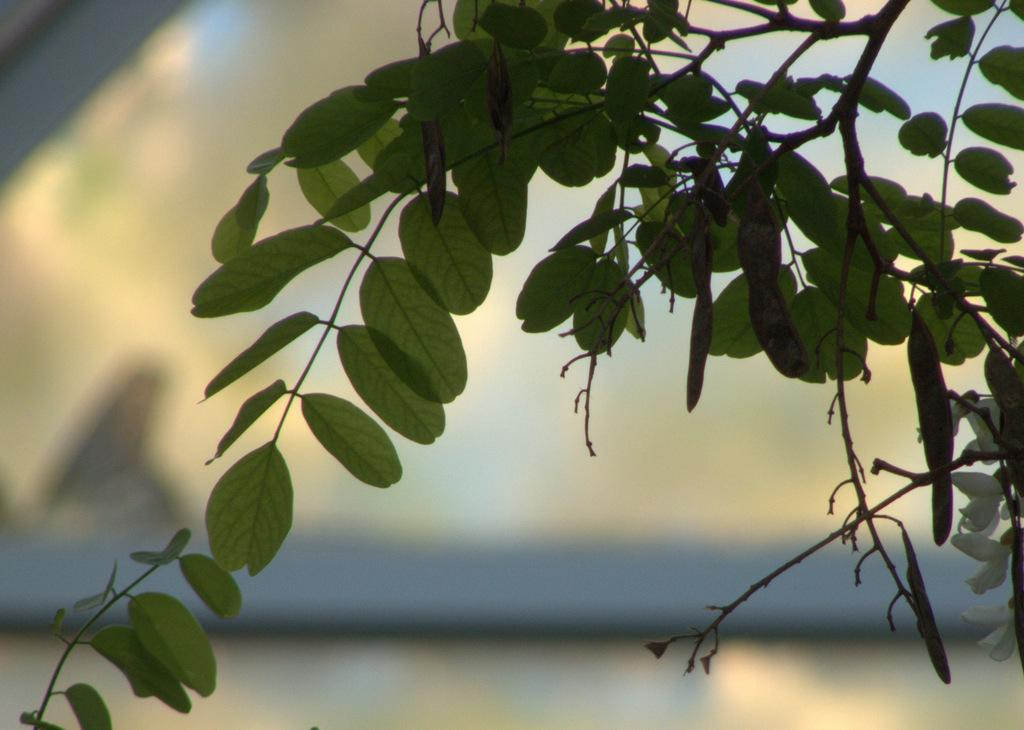What is the main subject of the image? The main subject of the image is a branch with leaves. Can you describe the branch in more detail? The branch appears to have leaves on it, indicating that it is from a tree or plant. What type of cracker is being held by the toad in the image? There is no toad or cracker present in the image; it only features a branch with leaves. 